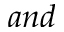<formula> <loc_0><loc_0><loc_500><loc_500>a n d</formula> 